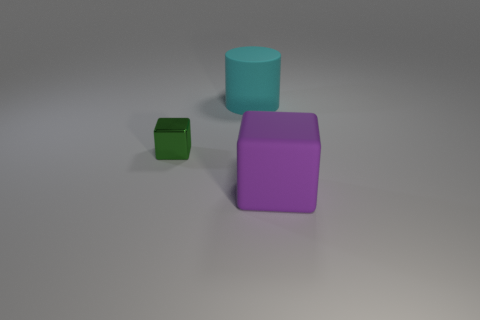What other shapes and colors are present in the image aside from the green cube? In addition to the small green cube, the image features a larger purple cube and a teal cylinder. The cubes have a smooth, matte appearance, while the cylinder shares the same finish and is distinguished by its rounded shape. 